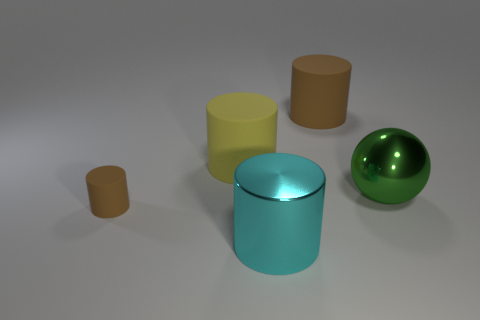If these objects were part of a game, what could be their purpose? If these objects were part of a game, they could serve various purposes based on their shapes and sizes. The cylinders might act as pieces that need to be stacked or ordered by size, while the reflective properties of the metal cylinder and the glossy sphere could be elements of a puzzle where one must direct light or align them in a specific manner to achieve an objective. 